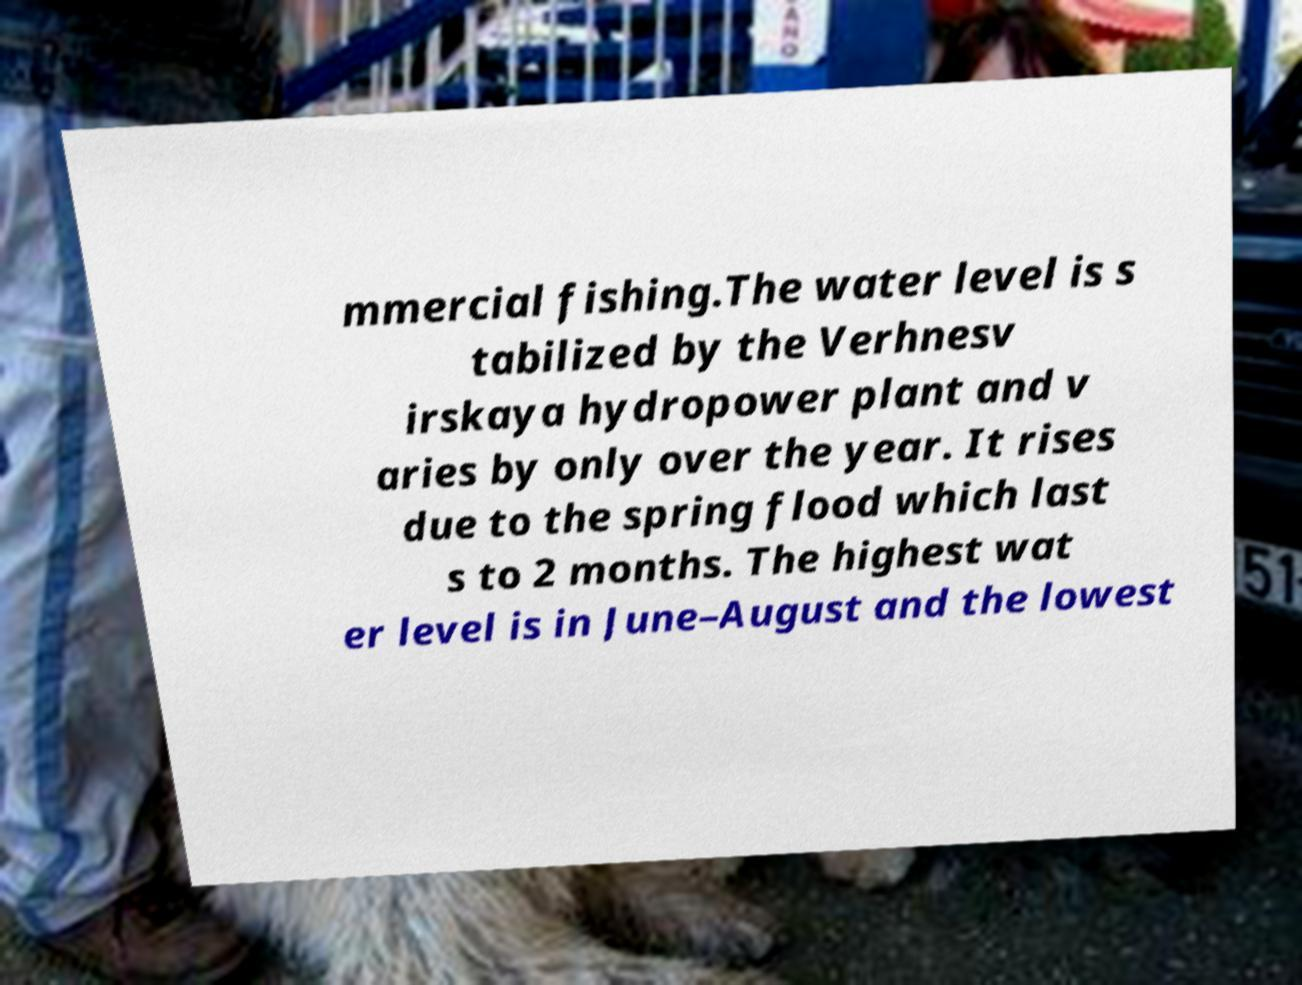Please read and relay the text visible in this image. What does it say? mmercial fishing.The water level is s tabilized by the Verhnesv irskaya hydropower plant and v aries by only over the year. It rises due to the spring flood which last s to 2 months. The highest wat er level is in June–August and the lowest 